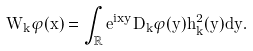<formula> <loc_0><loc_0><loc_500><loc_500>W _ { k } \varphi ( x ) = \int _ { \mathbb { R } } e ^ { i x y } D _ { k } \varphi ( y ) h _ { k } ^ { 2 } ( y ) d y .</formula> 